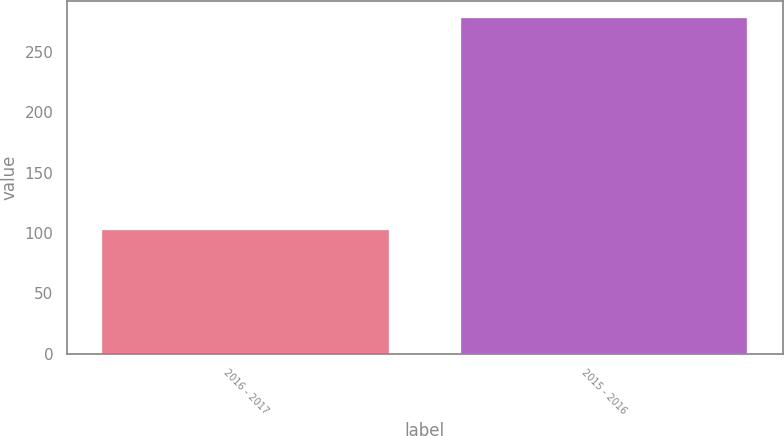<chart> <loc_0><loc_0><loc_500><loc_500><bar_chart><fcel>2016 - 2017<fcel>2015 - 2016<nl><fcel>102.3<fcel>277.8<nl></chart> 